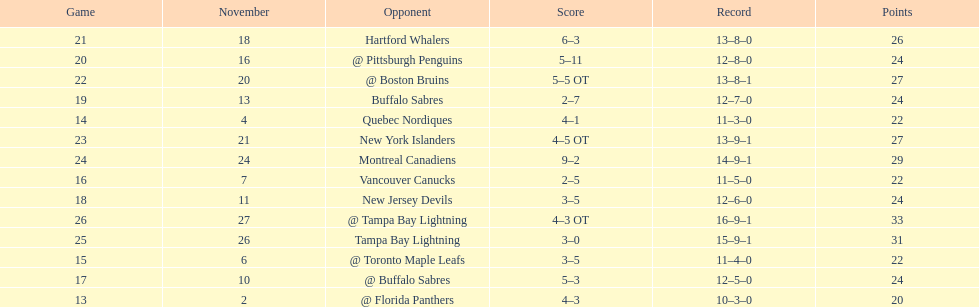Did the tampa bay lightning have the least amount of wins? Yes. 